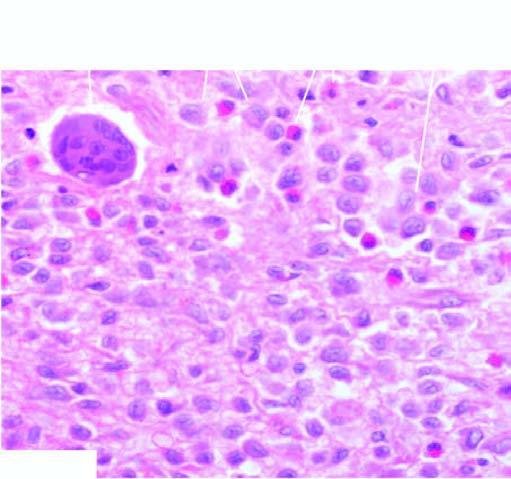did aemosiderin pigment in the cytoplasm of hepatocytes have vesicular nuclei admixed with eosinophils?
Answer the question using a single word or phrase. No 